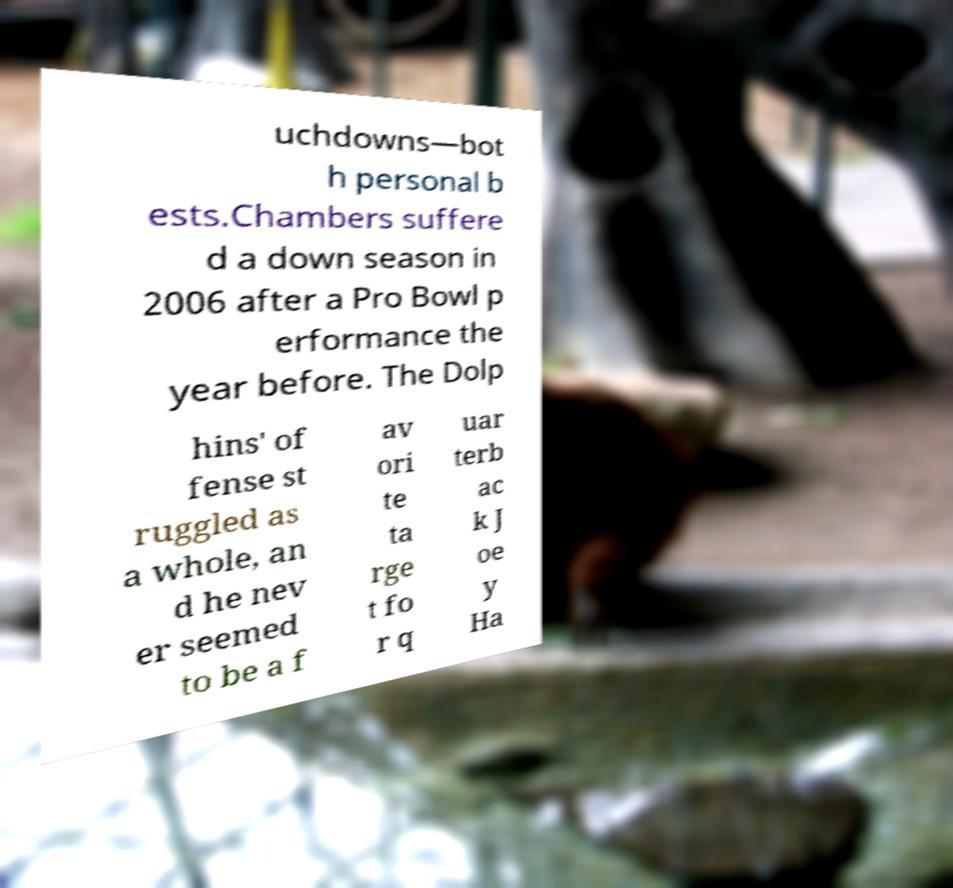Please identify and transcribe the text found in this image. uchdowns—bot h personal b ests.Chambers suffere d a down season in 2006 after a Pro Bowl p erformance the year before. The Dolp hins' of fense st ruggled as a whole, an d he nev er seemed to be a f av ori te ta rge t fo r q uar terb ac k J oe y Ha 